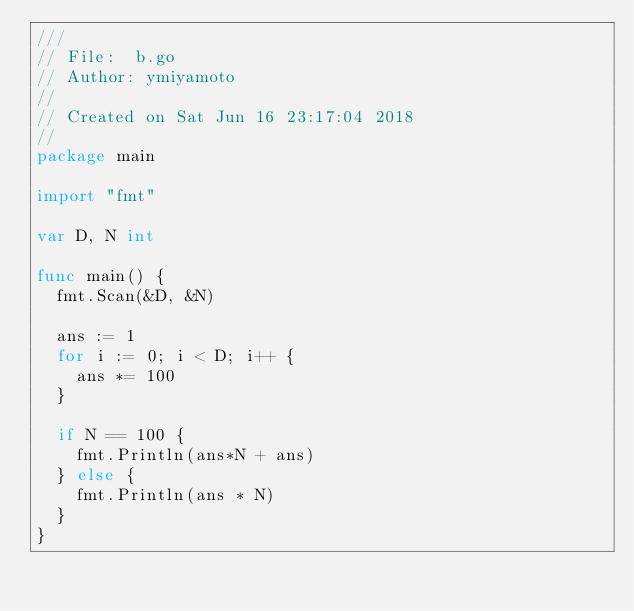<code> <loc_0><loc_0><loc_500><loc_500><_Go_>///
// File:  b.go
// Author: ymiyamoto
//
// Created on Sat Jun 16 23:17:04 2018
//
package main

import "fmt"

var D, N int

func main() {
	fmt.Scan(&D, &N)

	ans := 1
	for i := 0; i < D; i++ {
		ans *= 100
	}

	if N == 100 {
		fmt.Println(ans*N + ans)
	} else {
		fmt.Println(ans * N)
	}
}
</code> 